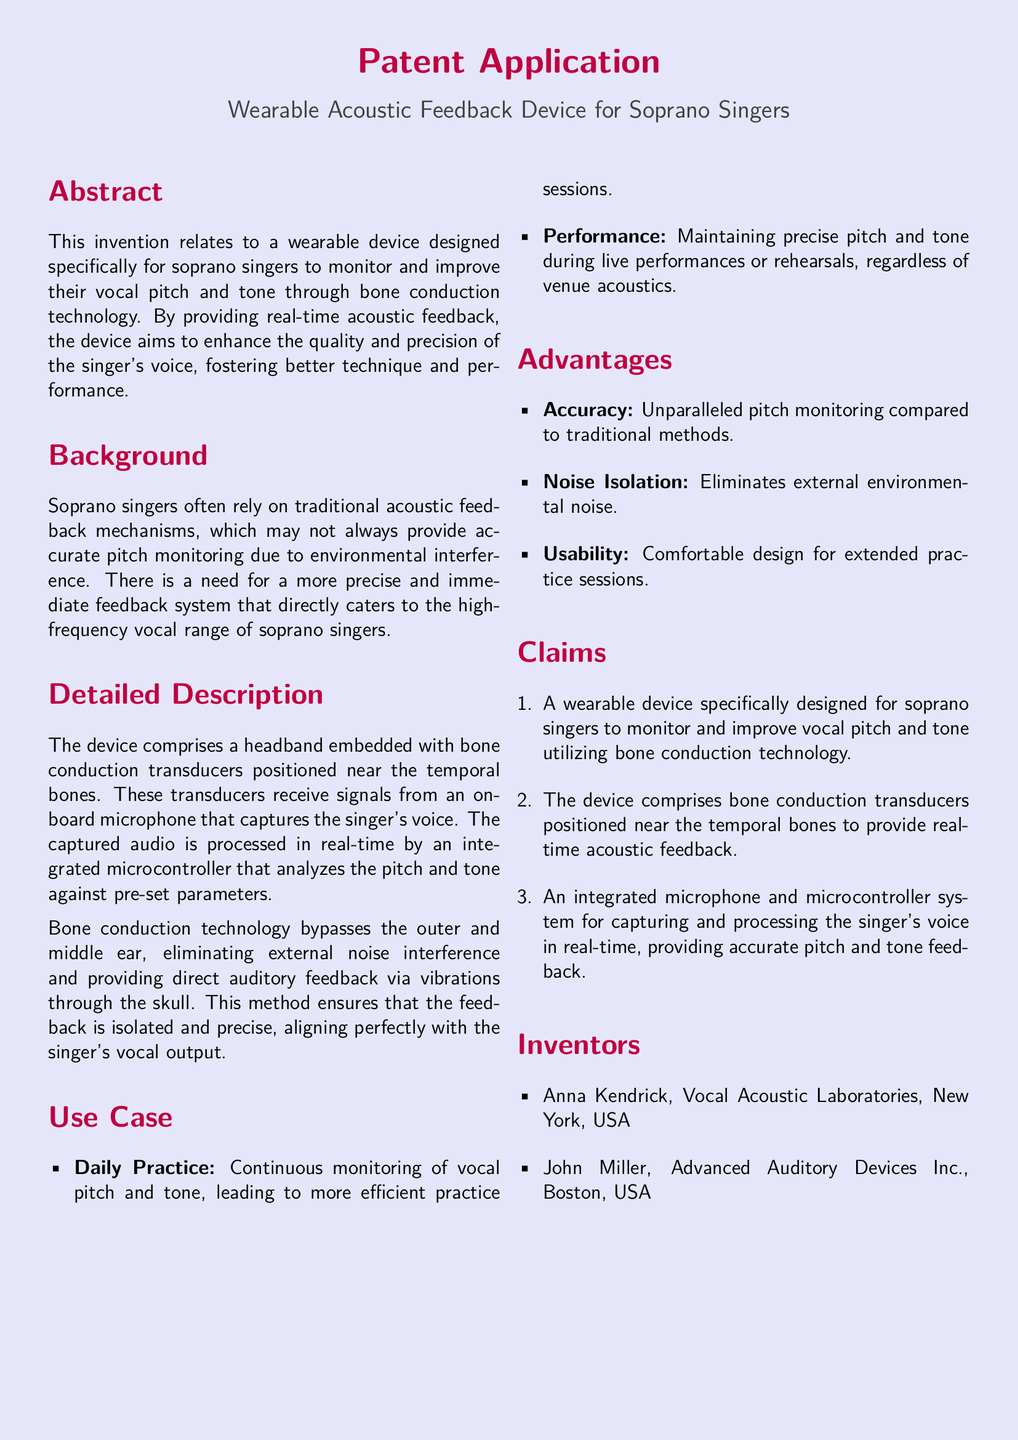What is the title of the patent application? The title is indicated prominently at the top of the document, which is "Wearable Acoustic Feedback Device for Soprano Singers."
Answer: Wearable Acoustic Feedback Device for Soprano Singers Who are the inventors of the device? The inventors are listed in the specific section of the document that contains their names and affiliations.
Answer: Anna Kendrick, John Miller What technology does the device utilize? The document specifies the technology used in the device, which is clearly stated in the description.
Answer: Bone conduction technology What are the two main use cases mentioned? The use cases are outlined in the section dedicated to them, specifically focusing on practice and performance.
Answer: Daily Practice, Performance What is one of the key advantages of the device? The advantages are listed in a section that highlights the benefits of using the device.
Answer: Accuracy How does the device provide feedback? The document describes the mechanism of how feedback is delivered to the user.
Answer: Real-time acoustic feedback What is the purpose of the integrated microcontroller? The purpose of the microcontroller is explained in the detailed description, elaborating on its function within the device.
Answer: Capturing and processing the singer's voice How many claims are listed in the patent application? The number of claims can be counted within the claims section of the document.
Answer: Three 